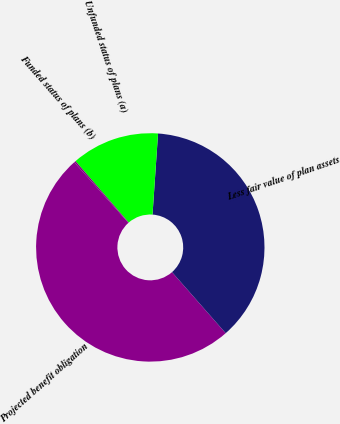Convert chart. <chart><loc_0><loc_0><loc_500><loc_500><pie_chart><fcel>Projected benefit obligation<fcel>Less fair value of plan assets<fcel>Unfunded status of plans (a)<fcel>Funded status of plans (b)<nl><fcel>49.89%<fcel>37.44%<fcel>12.45%<fcel>0.22%<nl></chart> 